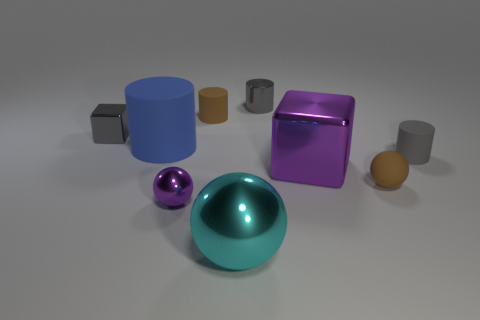Are there any patterns or designs on any of the objects in the scene? None of the objects in the image feature any discernible patterns or designs. Each object is a single solid color with a finish that ranges from matte to reflective, contributing to a minimalist aesthetic that emphasizes form and material over decoration. 